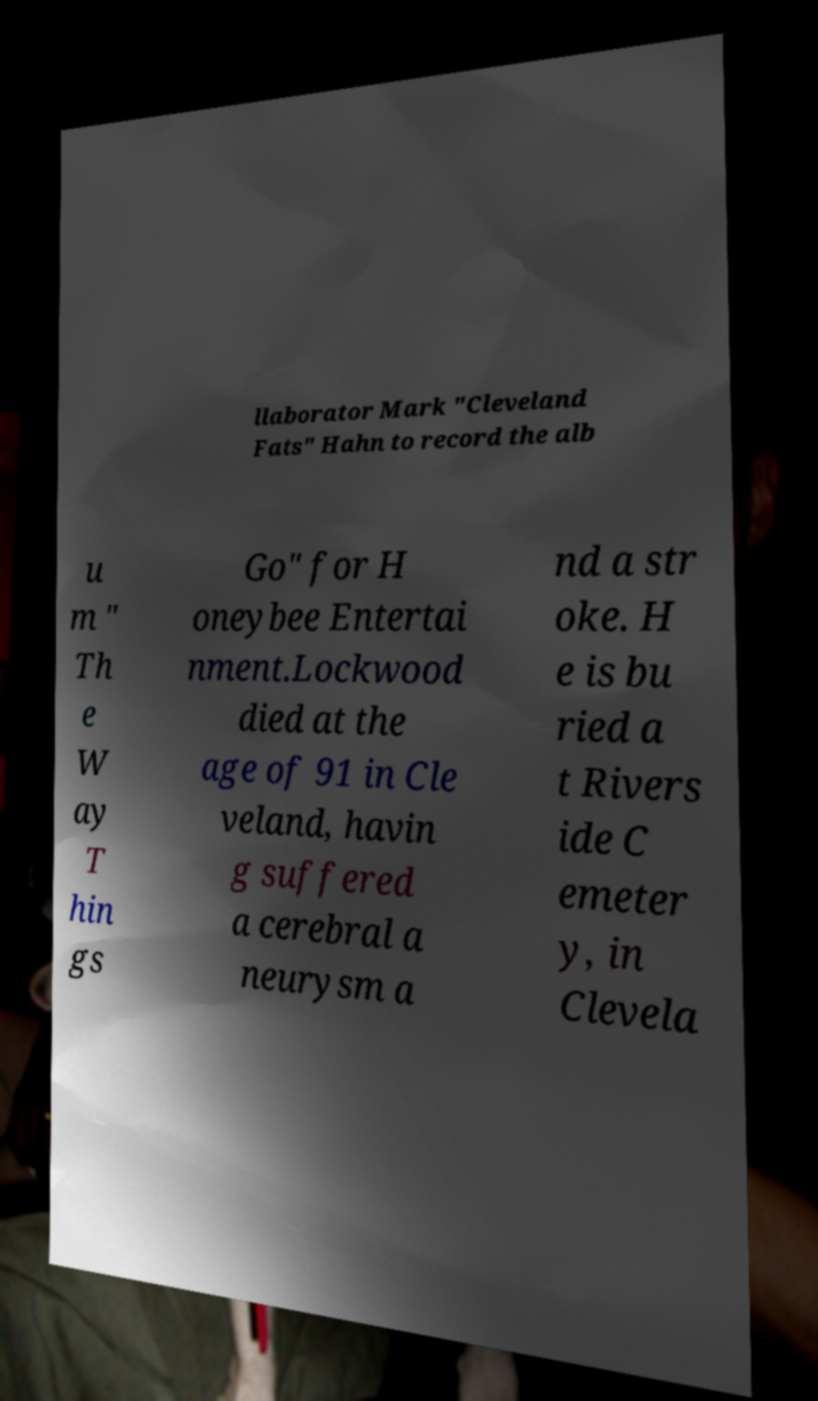Could you extract and type out the text from this image? llaborator Mark "Cleveland Fats" Hahn to record the alb u m " Th e W ay T hin gs Go" for H oneybee Entertai nment.Lockwood died at the age of 91 in Cle veland, havin g suffered a cerebral a neurysm a nd a str oke. H e is bu ried a t Rivers ide C emeter y, in Clevela 